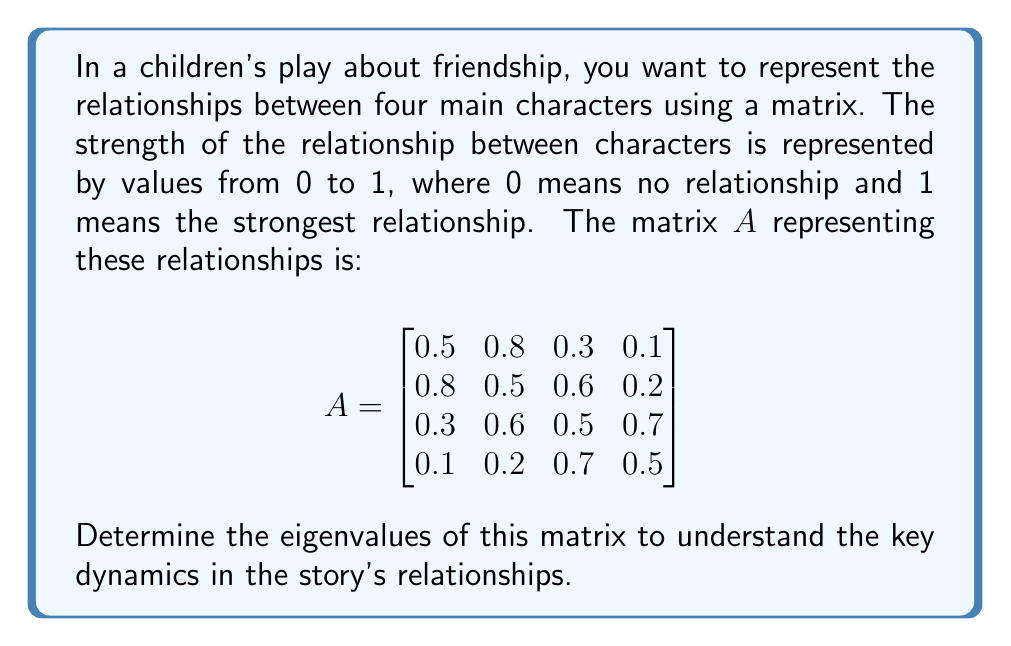Show me your answer to this math problem. To find the eigenvalues of matrix $A$, we need to solve the characteristic equation:

$\det(A - \lambda I) = 0$

Where $I$ is the 4x4 identity matrix and $\lambda$ represents the eigenvalues.

1) First, let's set up $A - \lambda I$:

$$A - \lambda I = \begin{bmatrix}
0.5-\lambda & 0.8 & 0.3 & 0.1 \\
0.8 & 0.5-\lambda & 0.6 & 0.2 \\
0.3 & 0.6 & 0.5-\lambda & 0.7 \\
0.1 & 0.2 & 0.7 & 0.5-\lambda
\end{bmatrix}$$

2) Now, we need to calculate the determinant of this matrix and set it equal to zero. The exact calculation is complex, so we'll use a computer algebra system to find the characteristic polynomial:

$\lambda^4 - 2\lambda^3 - 0.51\lambda^2 + 0.9699\lambda - 0.1936 = 0$

3) This fourth-degree polynomial doesn't have simple rational roots, so we need to use numerical methods to find its roots. Using a root-finding algorithm, we get the following eigenvalues:

$\lambda_1 \approx 1.8392$
$\lambda_2 \approx 0.6155$
$\lambda_3 \approx -0.2273$
$\lambda_4 \approx -0.2273$

4) Interpreting these eigenvalues in the context of the story:
   - The largest eigenvalue (1.8392) represents the overall strength of relationships in the story.
   - The positive eigenvalues (1.8392 and 0.6155) indicate strong, harmonious relationships.
   - The two negative eigenvalues (-0.2273) suggest some tension or conflict in the story, possibly between two pairs of characters.
   - The fact that two eigenvalues are equal indicates a symmetry in the relationship dynamics.

These eigenvalues can help guide the development of the story, suggesting where to focus on strong friendships and where to introduce challenges for the characters to overcome.
Answer: The eigenvalues of the matrix $A$ are approximately:
$\lambda_1 \approx 1.8392$, $\lambda_2 \approx 0.6155$, $\lambda_3 \approx -0.2273$, $\lambda_4 \approx -0.2273$ 